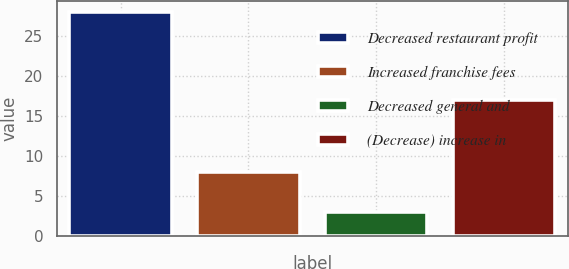Convert chart to OTSL. <chart><loc_0><loc_0><loc_500><loc_500><bar_chart><fcel>Decreased restaurant profit<fcel>Increased franchise fees<fcel>Decreased general and<fcel>(Decrease) increase in<nl><fcel>28<fcel>8<fcel>3<fcel>17<nl></chart> 